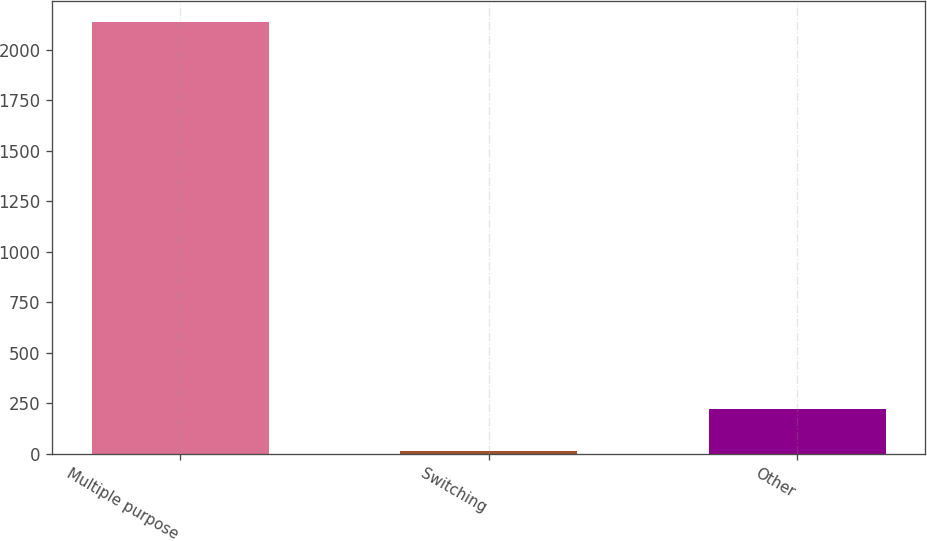Convert chart to OTSL. <chart><loc_0><loc_0><loc_500><loc_500><bar_chart><fcel>Multiple purpose<fcel>Switching<fcel>Other<nl><fcel>2135<fcel>12<fcel>224.3<nl></chart> 